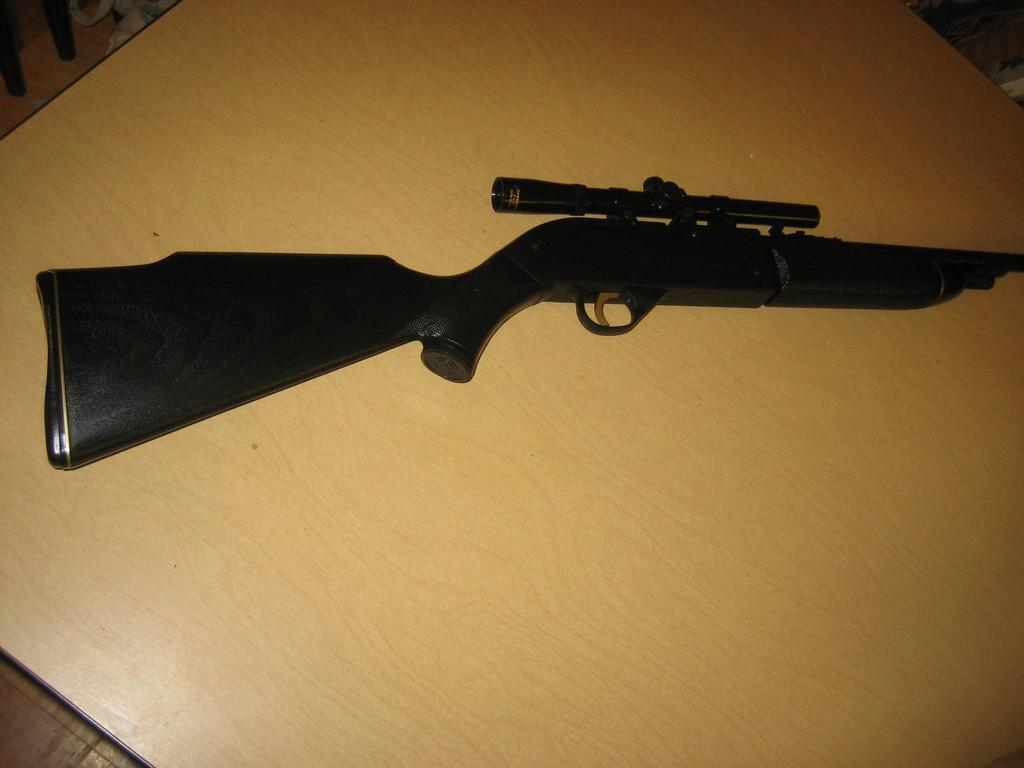What is the main object on the wooden surface in the image? There is a gun on a wooden surface in the image. Can you describe any other objects or features in the image? There are objects in the top left corner of the image. What type of wrench is being used to open the volcano in the image? There is no wrench or volcano present in the image. 